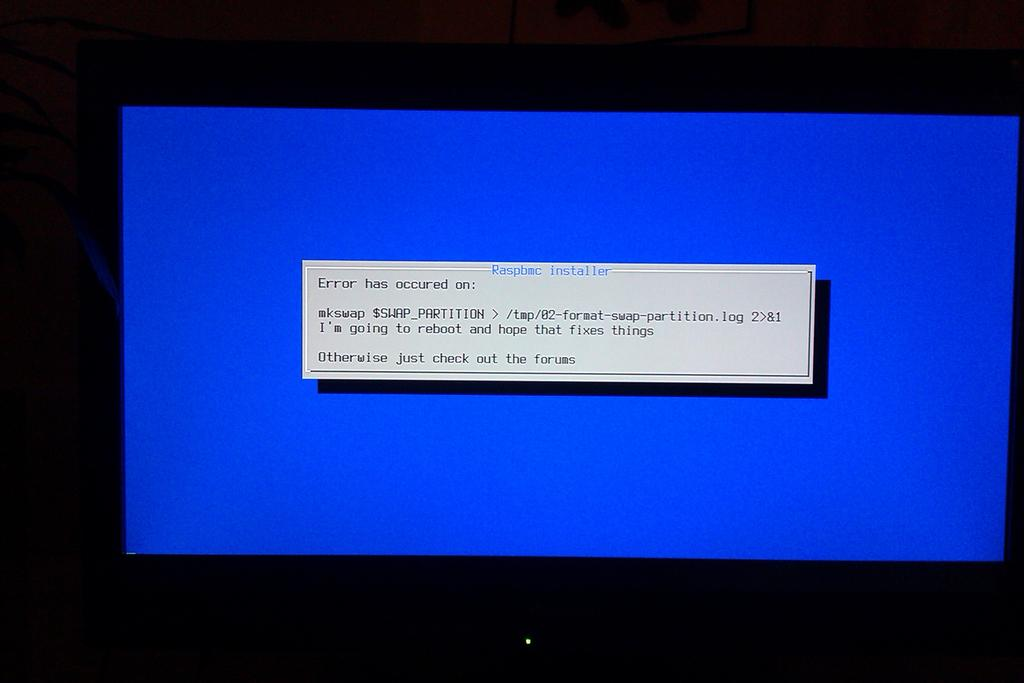<image>
Create a compact narrative representing the image presented. A computer screen with a Raspbmc installation error. 